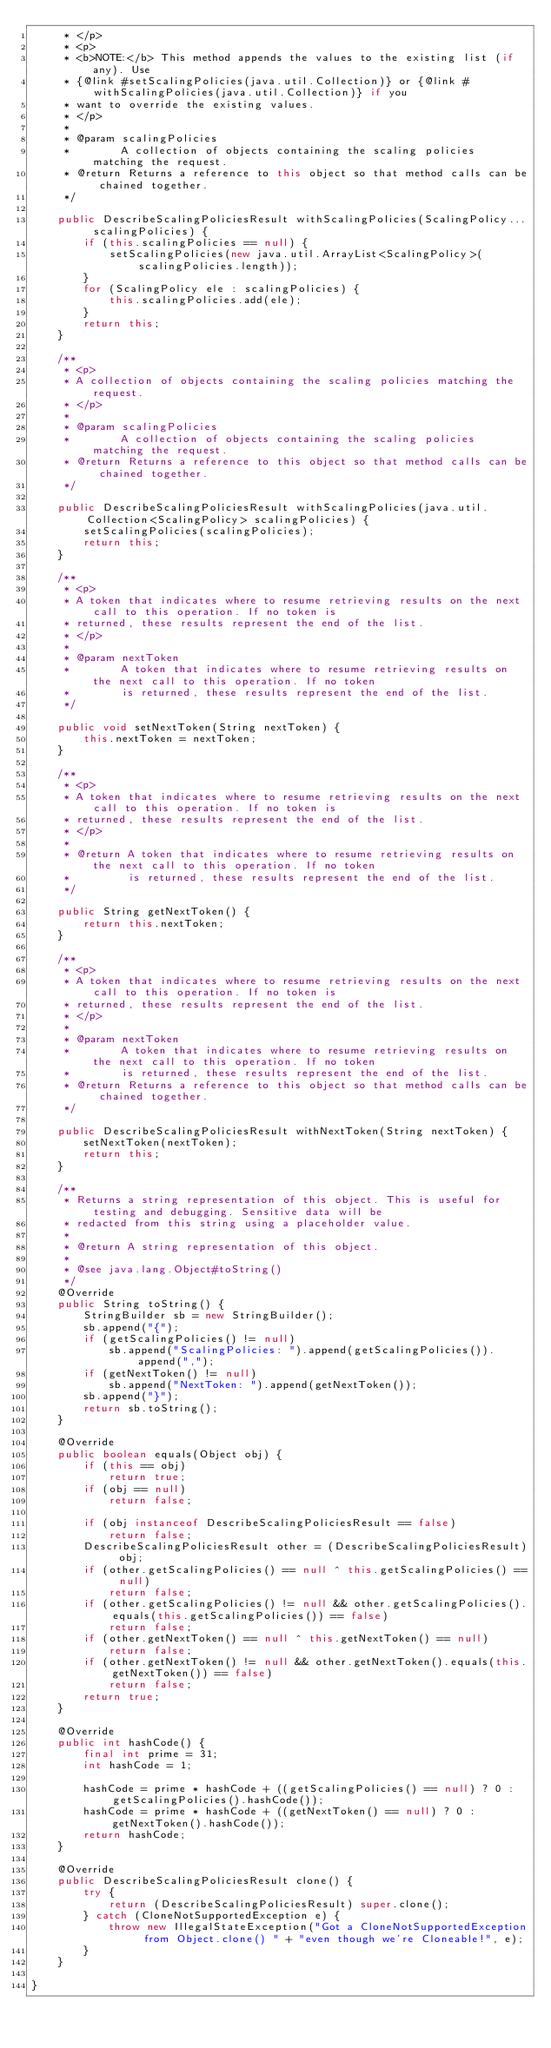Convert code to text. <code><loc_0><loc_0><loc_500><loc_500><_Java_>     * </p>
     * <p>
     * <b>NOTE:</b> This method appends the values to the existing list (if any). Use
     * {@link #setScalingPolicies(java.util.Collection)} or {@link #withScalingPolicies(java.util.Collection)} if you
     * want to override the existing values.
     * </p>
     * 
     * @param scalingPolicies
     *        A collection of objects containing the scaling policies matching the request.
     * @return Returns a reference to this object so that method calls can be chained together.
     */

    public DescribeScalingPoliciesResult withScalingPolicies(ScalingPolicy... scalingPolicies) {
        if (this.scalingPolicies == null) {
            setScalingPolicies(new java.util.ArrayList<ScalingPolicy>(scalingPolicies.length));
        }
        for (ScalingPolicy ele : scalingPolicies) {
            this.scalingPolicies.add(ele);
        }
        return this;
    }

    /**
     * <p>
     * A collection of objects containing the scaling policies matching the request.
     * </p>
     * 
     * @param scalingPolicies
     *        A collection of objects containing the scaling policies matching the request.
     * @return Returns a reference to this object so that method calls can be chained together.
     */

    public DescribeScalingPoliciesResult withScalingPolicies(java.util.Collection<ScalingPolicy> scalingPolicies) {
        setScalingPolicies(scalingPolicies);
        return this;
    }

    /**
     * <p>
     * A token that indicates where to resume retrieving results on the next call to this operation. If no token is
     * returned, these results represent the end of the list.
     * </p>
     * 
     * @param nextToken
     *        A token that indicates where to resume retrieving results on the next call to this operation. If no token
     *        is returned, these results represent the end of the list.
     */

    public void setNextToken(String nextToken) {
        this.nextToken = nextToken;
    }

    /**
     * <p>
     * A token that indicates where to resume retrieving results on the next call to this operation. If no token is
     * returned, these results represent the end of the list.
     * </p>
     * 
     * @return A token that indicates where to resume retrieving results on the next call to this operation. If no token
     *         is returned, these results represent the end of the list.
     */

    public String getNextToken() {
        return this.nextToken;
    }

    /**
     * <p>
     * A token that indicates where to resume retrieving results on the next call to this operation. If no token is
     * returned, these results represent the end of the list.
     * </p>
     * 
     * @param nextToken
     *        A token that indicates where to resume retrieving results on the next call to this operation. If no token
     *        is returned, these results represent the end of the list.
     * @return Returns a reference to this object so that method calls can be chained together.
     */

    public DescribeScalingPoliciesResult withNextToken(String nextToken) {
        setNextToken(nextToken);
        return this;
    }

    /**
     * Returns a string representation of this object. This is useful for testing and debugging. Sensitive data will be
     * redacted from this string using a placeholder value.
     *
     * @return A string representation of this object.
     *
     * @see java.lang.Object#toString()
     */
    @Override
    public String toString() {
        StringBuilder sb = new StringBuilder();
        sb.append("{");
        if (getScalingPolicies() != null)
            sb.append("ScalingPolicies: ").append(getScalingPolicies()).append(",");
        if (getNextToken() != null)
            sb.append("NextToken: ").append(getNextToken());
        sb.append("}");
        return sb.toString();
    }

    @Override
    public boolean equals(Object obj) {
        if (this == obj)
            return true;
        if (obj == null)
            return false;

        if (obj instanceof DescribeScalingPoliciesResult == false)
            return false;
        DescribeScalingPoliciesResult other = (DescribeScalingPoliciesResult) obj;
        if (other.getScalingPolicies() == null ^ this.getScalingPolicies() == null)
            return false;
        if (other.getScalingPolicies() != null && other.getScalingPolicies().equals(this.getScalingPolicies()) == false)
            return false;
        if (other.getNextToken() == null ^ this.getNextToken() == null)
            return false;
        if (other.getNextToken() != null && other.getNextToken().equals(this.getNextToken()) == false)
            return false;
        return true;
    }

    @Override
    public int hashCode() {
        final int prime = 31;
        int hashCode = 1;

        hashCode = prime * hashCode + ((getScalingPolicies() == null) ? 0 : getScalingPolicies().hashCode());
        hashCode = prime * hashCode + ((getNextToken() == null) ? 0 : getNextToken().hashCode());
        return hashCode;
    }

    @Override
    public DescribeScalingPoliciesResult clone() {
        try {
            return (DescribeScalingPoliciesResult) super.clone();
        } catch (CloneNotSupportedException e) {
            throw new IllegalStateException("Got a CloneNotSupportedException from Object.clone() " + "even though we're Cloneable!", e);
        }
    }

}
</code> 